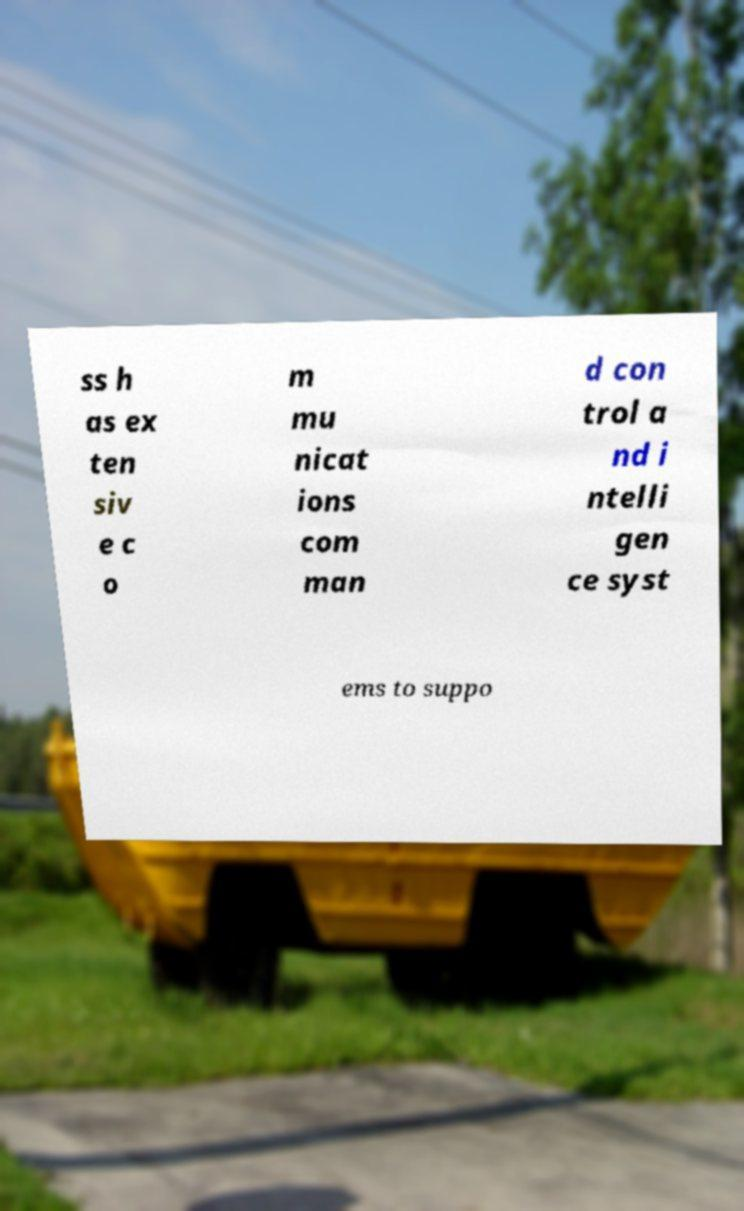There's text embedded in this image that I need extracted. Can you transcribe it verbatim? ss h as ex ten siv e c o m mu nicat ions com man d con trol a nd i ntelli gen ce syst ems to suppo 